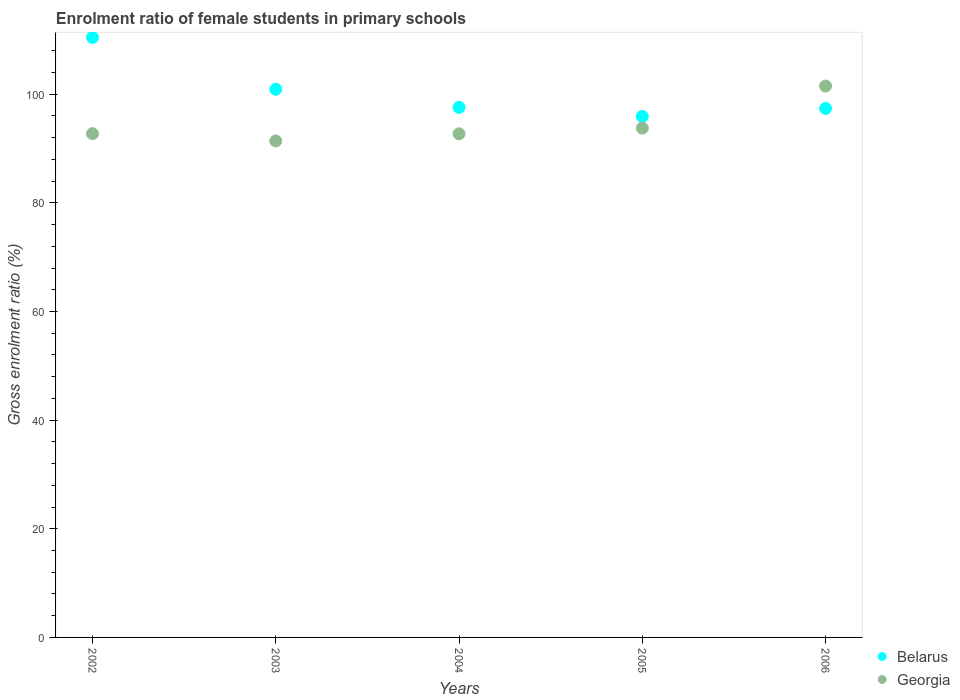What is the enrolment ratio of female students in primary schools in Georgia in 2003?
Offer a very short reply. 91.4. Across all years, what is the maximum enrolment ratio of female students in primary schools in Belarus?
Your response must be concise. 110.46. Across all years, what is the minimum enrolment ratio of female students in primary schools in Georgia?
Offer a terse response. 91.4. In which year was the enrolment ratio of female students in primary schools in Belarus minimum?
Provide a short and direct response. 2005. What is the total enrolment ratio of female students in primary schools in Belarus in the graph?
Make the answer very short. 502.26. What is the difference between the enrolment ratio of female students in primary schools in Belarus in 2003 and that in 2005?
Your answer should be very brief. 5. What is the difference between the enrolment ratio of female students in primary schools in Belarus in 2006 and the enrolment ratio of female students in primary schools in Georgia in 2003?
Your answer should be very brief. 5.98. What is the average enrolment ratio of female students in primary schools in Belarus per year?
Your response must be concise. 100.45. In the year 2005, what is the difference between the enrolment ratio of female students in primary schools in Belarus and enrolment ratio of female students in primary schools in Georgia?
Give a very brief answer. 2.15. In how many years, is the enrolment ratio of female students in primary schools in Belarus greater than 84 %?
Keep it short and to the point. 5. What is the ratio of the enrolment ratio of female students in primary schools in Belarus in 2002 to that in 2003?
Ensure brevity in your answer.  1.09. What is the difference between the highest and the second highest enrolment ratio of female students in primary schools in Georgia?
Make the answer very short. 7.74. What is the difference between the highest and the lowest enrolment ratio of female students in primary schools in Belarus?
Your answer should be compact. 14.54. Does the enrolment ratio of female students in primary schools in Belarus monotonically increase over the years?
Your response must be concise. No. How many dotlines are there?
Provide a short and direct response. 2. How many years are there in the graph?
Ensure brevity in your answer.  5. Does the graph contain grids?
Offer a very short reply. No. Where does the legend appear in the graph?
Offer a very short reply. Bottom right. How many legend labels are there?
Your response must be concise. 2. What is the title of the graph?
Keep it short and to the point. Enrolment ratio of female students in primary schools. Does "Chad" appear as one of the legend labels in the graph?
Offer a terse response. No. What is the label or title of the Y-axis?
Your answer should be compact. Gross enrolment ratio (%). What is the Gross enrolment ratio (%) of Belarus in 2002?
Provide a succinct answer. 110.46. What is the Gross enrolment ratio (%) in Georgia in 2002?
Provide a succinct answer. 92.74. What is the Gross enrolment ratio (%) in Belarus in 2003?
Give a very brief answer. 100.92. What is the Gross enrolment ratio (%) of Georgia in 2003?
Ensure brevity in your answer.  91.4. What is the Gross enrolment ratio (%) of Belarus in 2004?
Your response must be concise. 97.58. What is the Gross enrolment ratio (%) in Georgia in 2004?
Offer a very short reply. 92.72. What is the Gross enrolment ratio (%) in Belarus in 2005?
Offer a terse response. 95.92. What is the Gross enrolment ratio (%) in Georgia in 2005?
Your answer should be compact. 93.77. What is the Gross enrolment ratio (%) in Belarus in 2006?
Make the answer very short. 97.38. What is the Gross enrolment ratio (%) of Georgia in 2006?
Offer a very short reply. 101.51. Across all years, what is the maximum Gross enrolment ratio (%) of Belarus?
Ensure brevity in your answer.  110.46. Across all years, what is the maximum Gross enrolment ratio (%) of Georgia?
Your answer should be very brief. 101.51. Across all years, what is the minimum Gross enrolment ratio (%) of Belarus?
Your answer should be very brief. 95.92. Across all years, what is the minimum Gross enrolment ratio (%) of Georgia?
Your answer should be compact. 91.4. What is the total Gross enrolment ratio (%) of Belarus in the graph?
Offer a terse response. 502.26. What is the total Gross enrolment ratio (%) in Georgia in the graph?
Make the answer very short. 472.14. What is the difference between the Gross enrolment ratio (%) in Belarus in 2002 and that in 2003?
Provide a short and direct response. 9.54. What is the difference between the Gross enrolment ratio (%) of Georgia in 2002 and that in 2003?
Provide a succinct answer. 1.34. What is the difference between the Gross enrolment ratio (%) of Belarus in 2002 and that in 2004?
Keep it short and to the point. 12.88. What is the difference between the Gross enrolment ratio (%) of Georgia in 2002 and that in 2004?
Keep it short and to the point. 0.02. What is the difference between the Gross enrolment ratio (%) of Belarus in 2002 and that in 2005?
Offer a very short reply. 14.54. What is the difference between the Gross enrolment ratio (%) of Georgia in 2002 and that in 2005?
Your answer should be very brief. -1.02. What is the difference between the Gross enrolment ratio (%) in Belarus in 2002 and that in 2006?
Ensure brevity in your answer.  13.08. What is the difference between the Gross enrolment ratio (%) of Georgia in 2002 and that in 2006?
Give a very brief answer. -8.76. What is the difference between the Gross enrolment ratio (%) of Belarus in 2003 and that in 2004?
Keep it short and to the point. 3.34. What is the difference between the Gross enrolment ratio (%) of Georgia in 2003 and that in 2004?
Your answer should be compact. -1.32. What is the difference between the Gross enrolment ratio (%) in Belarus in 2003 and that in 2005?
Make the answer very short. 5. What is the difference between the Gross enrolment ratio (%) of Georgia in 2003 and that in 2005?
Make the answer very short. -2.37. What is the difference between the Gross enrolment ratio (%) in Belarus in 2003 and that in 2006?
Your response must be concise. 3.54. What is the difference between the Gross enrolment ratio (%) in Georgia in 2003 and that in 2006?
Offer a terse response. -10.11. What is the difference between the Gross enrolment ratio (%) of Belarus in 2004 and that in 2005?
Make the answer very short. 1.66. What is the difference between the Gross enrolment ratio (%) in Georgia in 2004 and that in 2005?
Keep it short and to the point. -1.05. What is the difference between the Gross enrolment ratio (%) in Belarus in 2004 and that in 2006?
Provide a short and direct response. 0.2. What is the difference between the Gross enrolment ratio (%) of Georgia in 2004 and that in 2006?
Provide a succinct answer. -8.79. What is the difference between the Gross enrolment ratio (%) of Belarus in 2005 and that in 2006?
Your answer should be compact. -1.46. What is the difference between the Gross enrolment ratio (%) of Georgia in 2005 and that in 2006?
Ensure brevity in your answer.  -7.74. What is the difference between the Gross enrolment ratio (%) of Belarus in 2002 and the Gross enrolment ratio (%) of Georgia in 2003?
Offer a terse response. 19.06. What is the difference between the Gross enrolment ratio (%) of Belarus in 2002 and the Gross enrolment ratio (%) of Georgia in 2004?
Keep it short and to the point. 17.74. What is the difference between the Gross enrolment ratio (%) of Belarus in 2002 and the Gross enrolment ratio (%) of Georgia in 2005?
Your response must be concise. 16.7. What is the difference between the Gross enrolment ratio (%) of Belarus in 2002 and the Gross enrolment ratio (%) of Georgia in 2006?
Provide a succinct answer. 8.96. What is the difference between the Gross enrolment ratio (%) in Belarus in 2003 and the Gross enrolment ratio (%) in Georgia in 2004?
Your answer should be very brief. 8.2. What is the difference between the Gross enrolment ratio (%) in Belarus in 2003 and the Gross enrolment ratio (%) in Georgia in 2005?
Offer a terse response. 7.15. What is the difference between the Gross enrolment ratio (%) in Belarus in 2003 and the Gross enrolment ratio (%) in Georgia in 2006?
Offer a very short reply. -0.59. What is the difference between the Gross enrolment ratio (%) in Belarus in 2004 and the Gross enrolment ratio (%) in Georgia in 2005?
Ensure brevity in your answer.  3.81. What is the difference between the Gross enrolment ratio (%) of Belarus in 2004 and the Gross enrolment ratio (%) of Georgia in 2006?
Ensure brevity in your answer.  -3.93. What is the difference between the Gross enrolment ratio (%) in Belarus in 2005 and the Gross enrolment ratio (%) in Georgia in 2006?
Provide a short and direct response. -5.59. What is the average Gross enrolment ratio (%) in Belarus per year?
Give a very brief answer. 100.45. What is the average Gross enrolment ratio (%) in Georgia per year?
Offer a very short reply. 94.43. In the year 2002, what is the difference between the Gross enrolment ratio (%) of Belarus and Gross enrolment ratio (%) of Georgia?
Give a very brief answer. 17.72. In the year 2003, what is the difference between the Gross enrolment ratio (%) of Belarus and Gross enrolment ratio (%) of Georgia?
Your answer should be very brief. 9.52. In the year 2004, what is the difference between the Gross enrolment ratio (%) in Belarus and Gross enrolment ratio (%) in Georgia?
Keep it short and to the point. 4.86. In the year 2005, what is the difference between the Gross enrolment ratio (%) of Belarus and Gross enrolment ratio (%) of Georgia?
Offer a very short reply. 2.15. In the year 2006, what is the difference between the Gross enrolment ratio (%) of Belarus and Gross enrolment ratio (%) of Georgia?
Your answer should be compact. -4.13. What is the ratio of the Gross enrolment ratio (%) of Belarus in 2002 to that in 2003?
Provide a short and direct response. 1.09. What is the ratio of the Gross enrolment ratio (%) in Georgia in 2002 to that in 2003?
Provide a succinct answer. 1.01. What is the ratio of the Gross enrolment ratio (%) in Belarus in 2002 to that in 2004?
Your answer should be compact. 1.13. What is the ratio of the Gross enrolment ratio (%) of Belarus in 2002 to that in 2005?
Provide a short and direct response. 1.15. What is the ratio of the Gross enrolment ratio (%) in Belarus in 2002 to that in 2006?
Offer a very short reply. 1.13. What is the ratio of the Gross enrolment ratio (%) of Georgia in 2002 to that in 2006?
Keep it short and to the point. 0.91. What is the ratio of the Gross enrolment ratio (%) of Belarus in 2003 to that in 2004?
Your response must be concise. 1.03. What is the ratio of the Gross enrolment ratio (%) of Georgia in 2003 to that in 2004?
Provide a succinct answer. 0.99. What is the ratio of the Gross enrolment ratio (%) in Belarus in 2003 to that in 2005?
Offer a terse response. 1.05. What is the ratio of the Gross enrolment ratio (%) in Georgia in 2003 to that in 2005?
Provide a short and direct response. 0.97. What is the ratio of the Gross enrolment ratio (%) in Belarus in 2003 to that in 2006?
Your response must be concise. 1.04. What is the ratio of the Gross enrolment ratio (%) in Georgia in 2003 to that in 2006?
Keep it short and to the point. 0.9. What is the ratio of the Gross enrolment ratio (%) in Belarus in 2004 to that in 2005?
Make the answer very short. 1.02. What is the ratio of the Gross enrolment ratio (%) in Belarus in 2004 to that in 2006?
Make the answer very short. 1. What is the ratio of the Gross enrolment ratio (%) in Georgia in 2004 to that in 2006?
Offer a terse response. 0.91. What is the ratio of the Gross enrolment ratio (%) in Georgia in 2005 to that in 2006?
Offer a very short reply. 0.92. What is the difference between the highest and the second highest Gross enrolment ratio (%) of Belarus?
Provide a short and direct response. 9.54. What is the difference between the highest and the second highest Gross enrolment ratio (%) in Georgia?
Ensure brevity in your answer.  7.74. What is the difference between the highest and the lowest Gross enrolment ratio (%) of Belarus?
Offer a very short reply. 14.54. What is the difference between the highest and the lowest Gross enrolment ratio (%) of Georgia?
Provide a succinct answer. 10.11. 